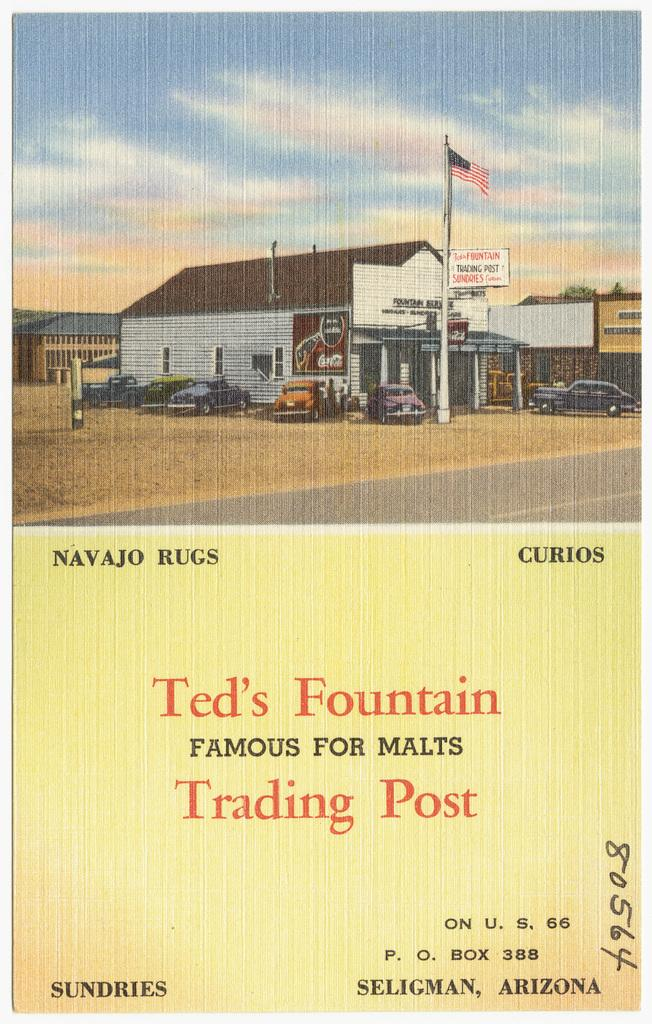<image>
Summarize the visual content of the image. Card for Ted's Fountain Trading Post which is in Arizona. 